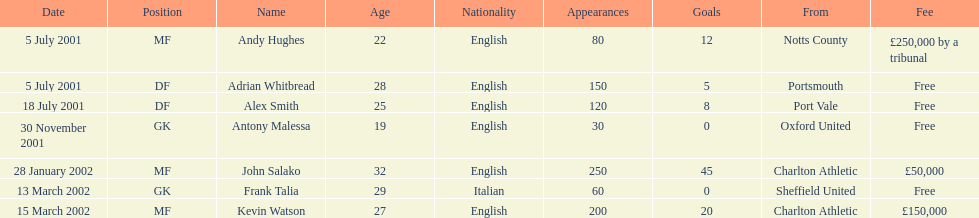What was the transfer fee to transfer kevin watson? £150,000. Could you help me parse every detail presented in this table? {'header': ['Date', 'Position', 'Name', 'Age', 'Nationality', 'Appearances', 'Goals', 'From', 'Fee'], 'rows': [['5 July 2001', 'MF', 'Andy Hughes', '22', 'English', '80', '12', 'Notts County', '£250,000 by a tribunal'], ['5 July 2001', 'DF', 'Adrian Whitbread', '28', 'English', '150', '5', 'Portsmouth', 'Free'], ['18 July 2001', 'DF', 'Alex Smith', '25', 'English', '120', '8', 'Port Vale', 'Free'], ['30 November 2001', 'GK', 'Antony Malessa', '19', 'English', '30', '0', 'Oxford United', 'Free'], ['28 January 2002', 'MF', 'John Salako', '32', 'English', '250', '45', 'Charlton Athletic', '£50,000'], ['13 March 2002', 'GK', 'Frank Talia', '29', 'Italian', '60', '0', 'Sheffield United', 'Free'], ['15 March 2002', 'MF', 'Kevin Watson', '27', 'English', '200', '20', 'Charlton Athletic', '£150,000']]} 